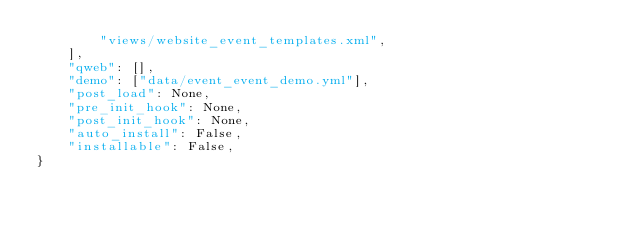<code> <loc_0><loc_0><loc_500><loc_500><_Python_>        "views/website_event_templates.xml",
    ],
    "qweb": [],
    "demo": ["data/event_event_demo.yml"],
    "post_load": None,
    "pre_init_hook": None,
    "post_init_hook": None,
    "auto_install": False,
    "installable": False,
}
</code> 